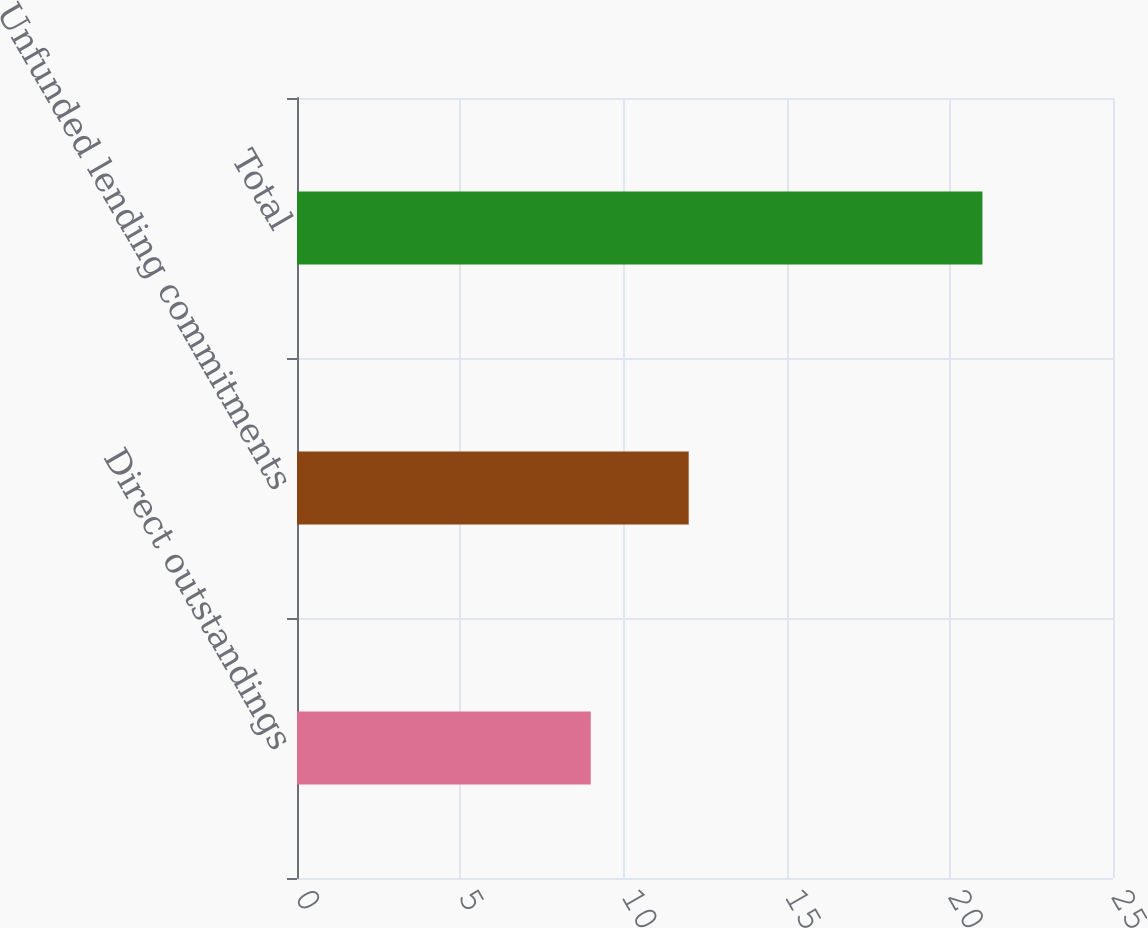Convert chart to OTSL. <chart><loc_0><loc_0><loc_500><loc_500><bar_chart><fcel>Direct outstandings<fcel>Unfunded lending commitments<fcel>Total<nl><fcel>9<fcel>12<fcel>21<nl></chart> 